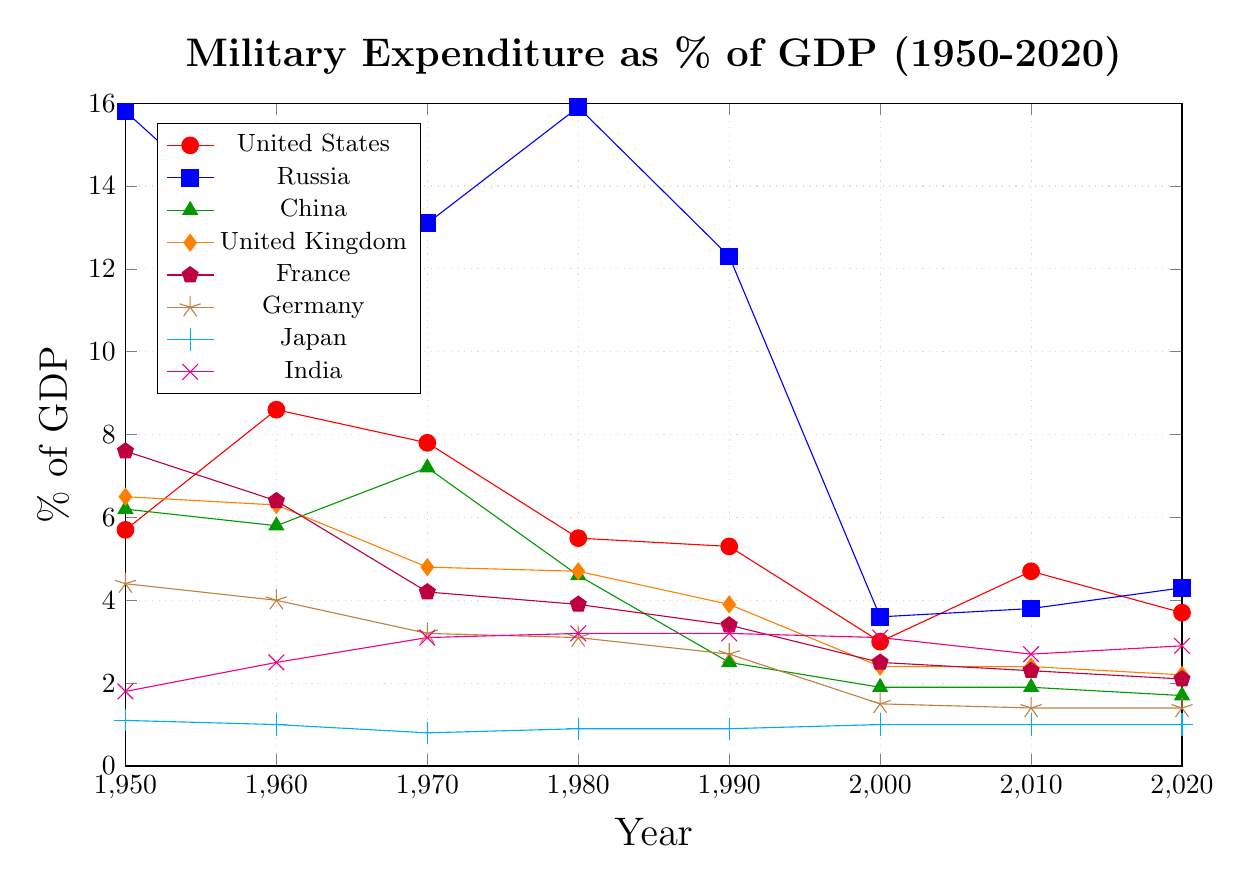What was the highest military expenditure as a percentage of GDP for the United States between 1950 and 2020? The highest percentage can be found by examining the United States' data points over the years. The values are 5.7, 8.6, 7.8, 5.5, 5.3, 3.0, 4.7, and 3.7. The highest value is 8.6 in 1960.
Answer: 8.6 How did the military expenditure as a percentage of GDP for Russia in 2000 compare to that of China in 2000? From the data, Russia's expenditure in 2000 was 3.6%, and China's was 1.9%. Comparing these, Russia's expenditure was higher than China's.
Answer: Russia's expenditure was higher Which country had the lowest military expenditure as a percentage of GDP in 1980? By comparing the expenditures of all countries in 1980: United States (5.5), Russia (15.9), China (4.6), United Kingdom (4.7), France (3.9), Germany (3.1), Japan (0.9), and India (3.2). The lowest value is for Japan at 0.9%.
Answer: Japan What was the difference in military expenditure as a percentage of GDP between India and Germany in 2020? In 2020, India's military expenditure was 2.9% and Germany's was 1.4%. The difference is 2.9 - 1.4 = 1.5%.
Answer: 1.5% Which two countries had nearly the same military expenditure percentages in 2010? In 2010, the expenditures were United States (4.7), Russia (3.8), China (1.9), United Kingdom (2.4), France (2.3), Germany (1.4), Japan (1.0), and India (2.7). France's (2.3) and the United Kingdom's (2.4) expenditure were nearly the same.
Answer: France and United Kingdom How did Japan's military expenditure as a percentage of GDP change from 1950 to 2020? Japan's expenditures were 1.1% in 1950 and 1.0% in 2020. The change can be calculated as 1.0 - 1.1 = -0.1%. Thus, it slightly decreased by 0.1%.
Answer: Decreased by 0.1% In which decade did France see the largest decrease in military expenditure as a percentage of GDP? Comparing decade-to-decade changes: 
1950 to 1960: 7.6 to 6.4 (-1.2), 
1960 to 1970: 6.4 to 4.2 (-2.2), 
1970 to 1980: 4.2 to 3.9 (-0.3), 
1980 to 1990: 3.9 to 3.4 (-0.5), 
1990 to 2000: 3.4 to 2.5 (-0.9), 
2000 to 2010: 2.5 to 2.3 (-0.2), 
2010 to 2020: 2.3 to 2.1 (-0.2). 
The largest decrease of 2.2% occurred between 1960 and 1970.
Answer: 1960 to 1970 What is the average military expenditure as a percentage of GDP for China over the given years? The values for China are 6.2, 5.8, 7.2, 4.6, 2.5, 1.9, 1.9, and 1.7. Adding them gives 31.8, and the average is 31.8 / 8 = 3.975%.
Answer: 3.975% What color represents Germany in the plot? Germany is represented with the color brown, as indicated by the legend in the plot.
Answer: Brown 